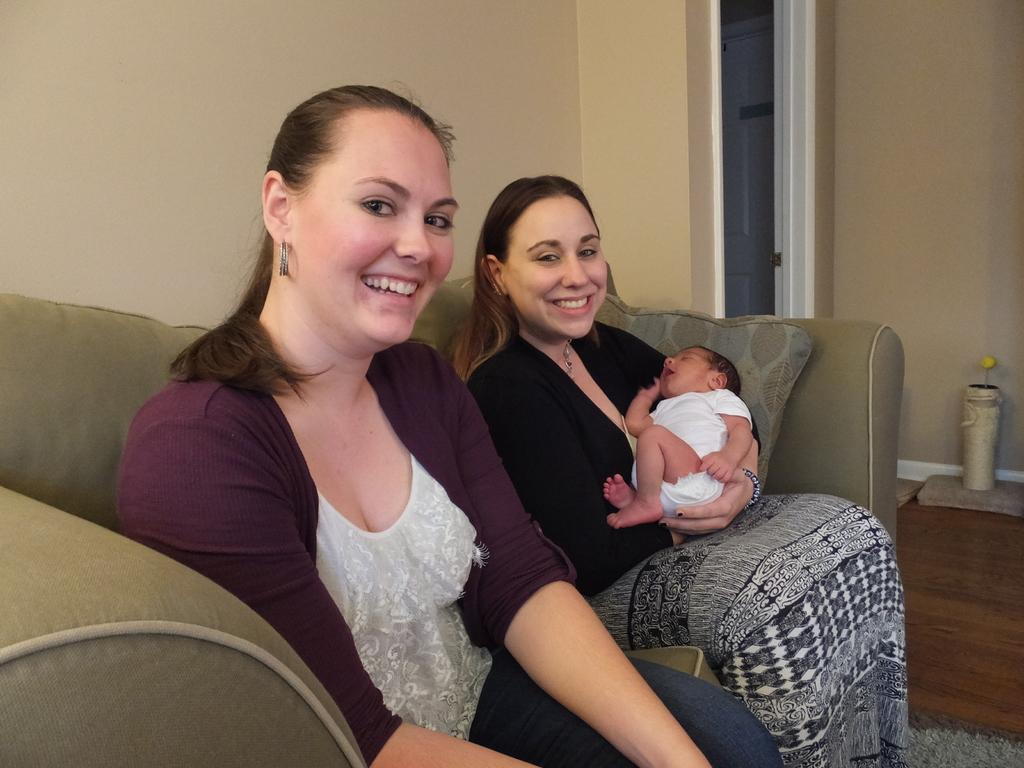How many people are in the image? There are two ladies in the image. What are the ladies doing in the image? The ladies are sitting on a sofa. Is there a baby present in the image? Yes, one of the ladies is holding a baby. What can be seen on the floor in the image? There is a flower vase on the floor. What type of watch is the baby wearing in the image? There is no watch visible on the baby in the image. Can you describe the tank that is present in the image? There is no tank present in the image. 